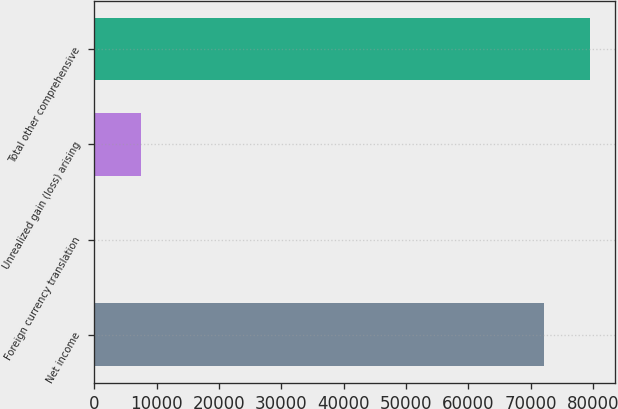<chart> <loc_0><loc_0><loc_500><loc_500><bar_chart><fcel>Net income<fcel>Foreign currency translation<fcel>Unrealized gain (loss) arising<fcel>Total other comprehensive<nl><fcel>72044<fcel>22<fcel>7442.4<fcel>79464.4<nl></chart> 